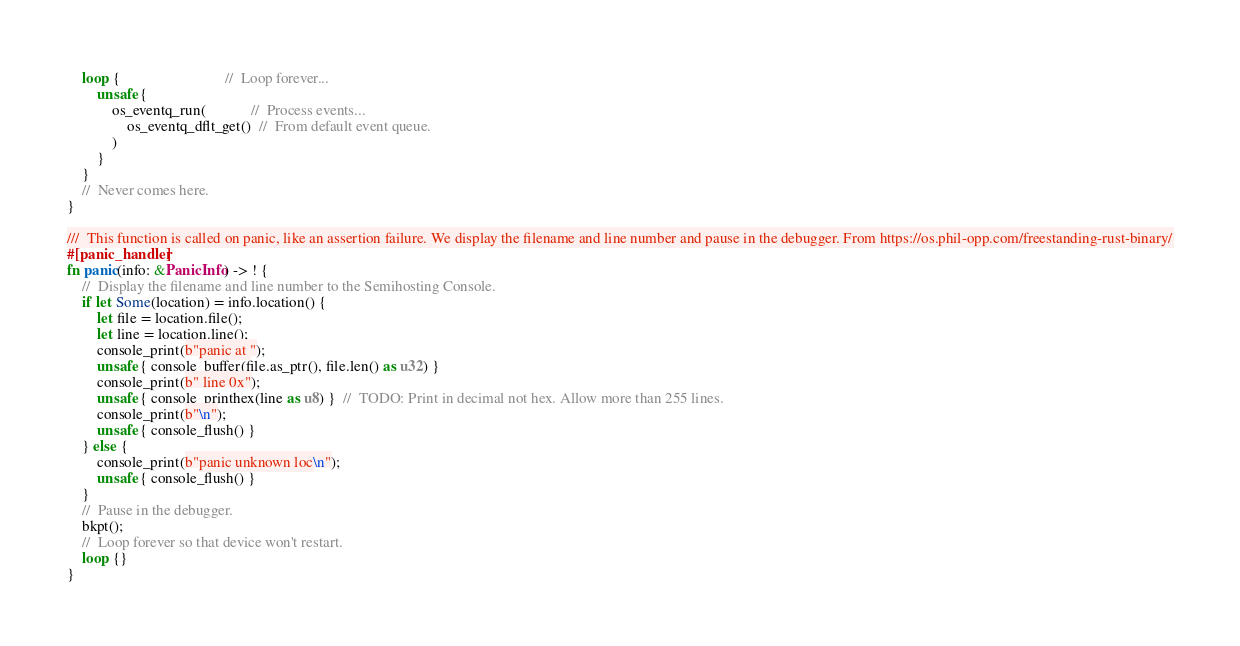Convert code to text. <code><loc_0><loc_0><loc_500><loc_500><_Rust_>    loop {                            //  Loop forever...
        unsafe {
            os_eventq_run(            //  Process events...
                os_eventq_dflt_get()  //  From default event queue.
            )
        }
    }
    //  Never comes here.
}

///  This function is called on panic, like an assertion failure. We display the filename and line number and pause in the debugger. From https://os.phil-opp.com/freestanding-rust-binary/
#[panic_handler]
fn panic(info: &PanicInfo) -> ! {
    //  Display the filename and line number to the Semihosting Console.
    if let Some(location) = info.location() {
        let file = location.file();
        let line = location.line();
        console_print(b"panic at ");
        unsafe { console_buffer(file.as_ptr(), file.len() as u32) }
        console_print(b" line 0x");
        unsafe { console_printhex(line as u8) }  //  TODO: Print in decimal not hex. Allow more than 255 lines.
        console_print(b"\n");
        unsafe { console_flush() }
    } else {
        console_print(b"panic unknown loc\n");
        unsafe { console_flush() }
    }
    //  Pause in the debugger.
    bkpt();
    //  Loop forever so that device won't restart.
    loop {}
}
</code> 